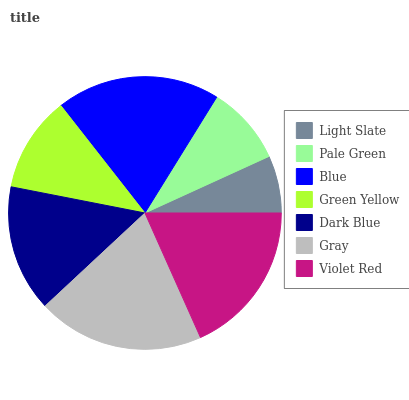Is Light Slate the minimum?
Answer yes or no. Yes. Is Gray the maximum?
Answer yes or no. Yes. Is Pale Green the minimum?
Answer yes or no. No. Is Pale Green the maximum?
Answer yes or no. No. Is Pale Green greater than Light Slate?
Answer yes or no. Yes. Is Light Slate less than Pale Green?
Answer yes or no. Yes. Is Light Slate greater than Pale Green?
Answer yes or no. No. Is Pale Green less than Light Slate?
Answer yes or no. No. Is Dark Blue the high median?
Answer yes or no. Yes. Is Dark Blue the low median?
Answer yes or no. Yes. Is Pale Green the high median?
Answer yes or no. No. Is Light Slate the low median?
Answer yes or no. No. 